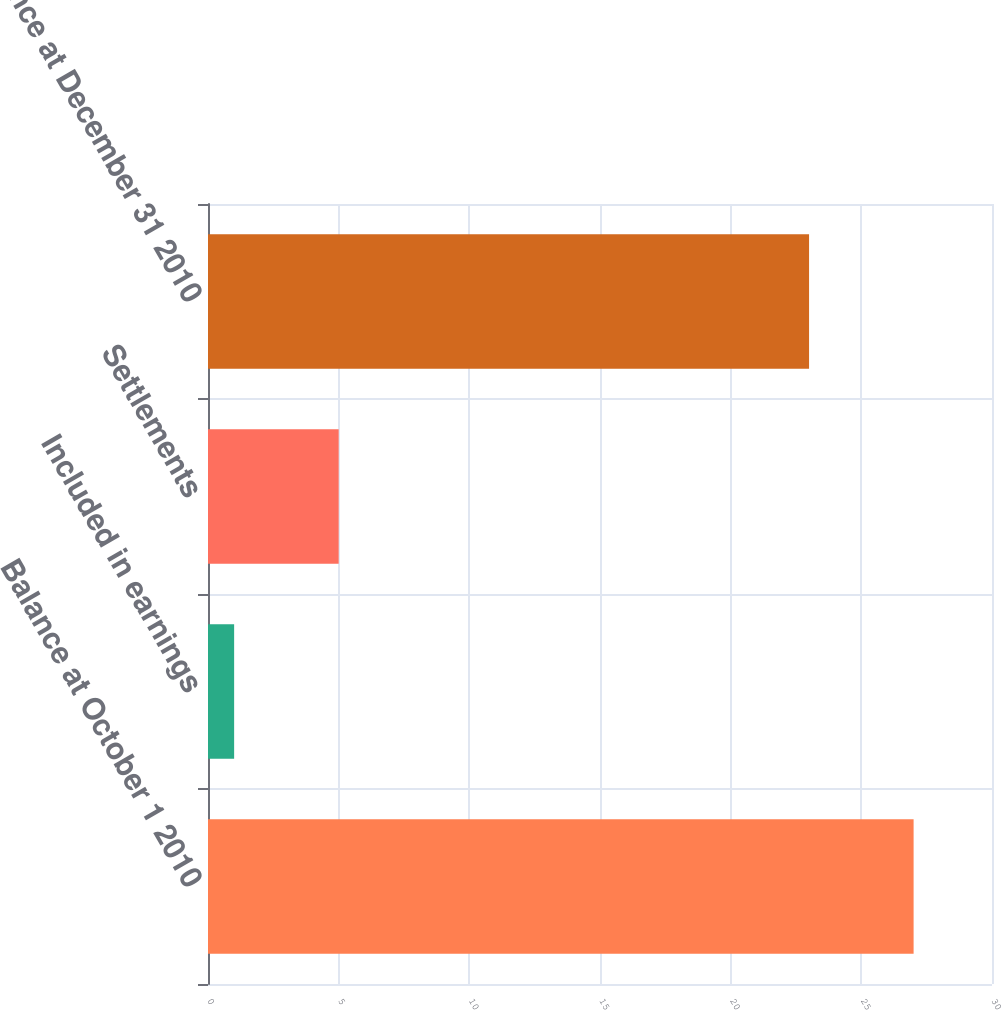Convert chart. <chart><loc_0><loc_0><loc_500><loc_500><bar_chart><fcel>Balance at October 1 2010<fcel>Included in earnings<fcel>Settlements<fcel>Balance at December 31 2010<nl><fcel>27<fcel>1<fcel>5<fcel>23<nl></chart> 